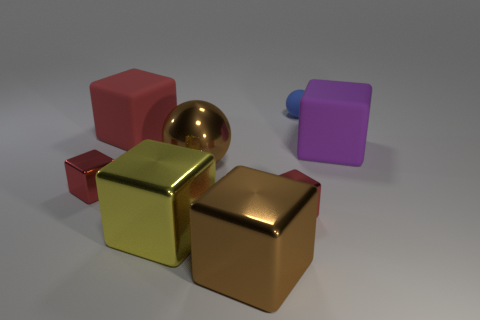What textures are present on the objects in this image? The objects in this image exhibit various textures. The small and large cubes have a matte finish, the small ball and two larger cubes have a reflective, metallic texture, and one object is partially obscured, but based on the visible edge, it likely has a matte texture as well. Can you tell me about the lighting used in this image? Certainly. The lighting in this image appears to be soft and diffused, with shadows indicating the light source is positioned above the objects. There are also subtle reflections on the metallic surfaces, which suggest that the environment around the objects is not brightly lit, allowing the objects to stand out. 